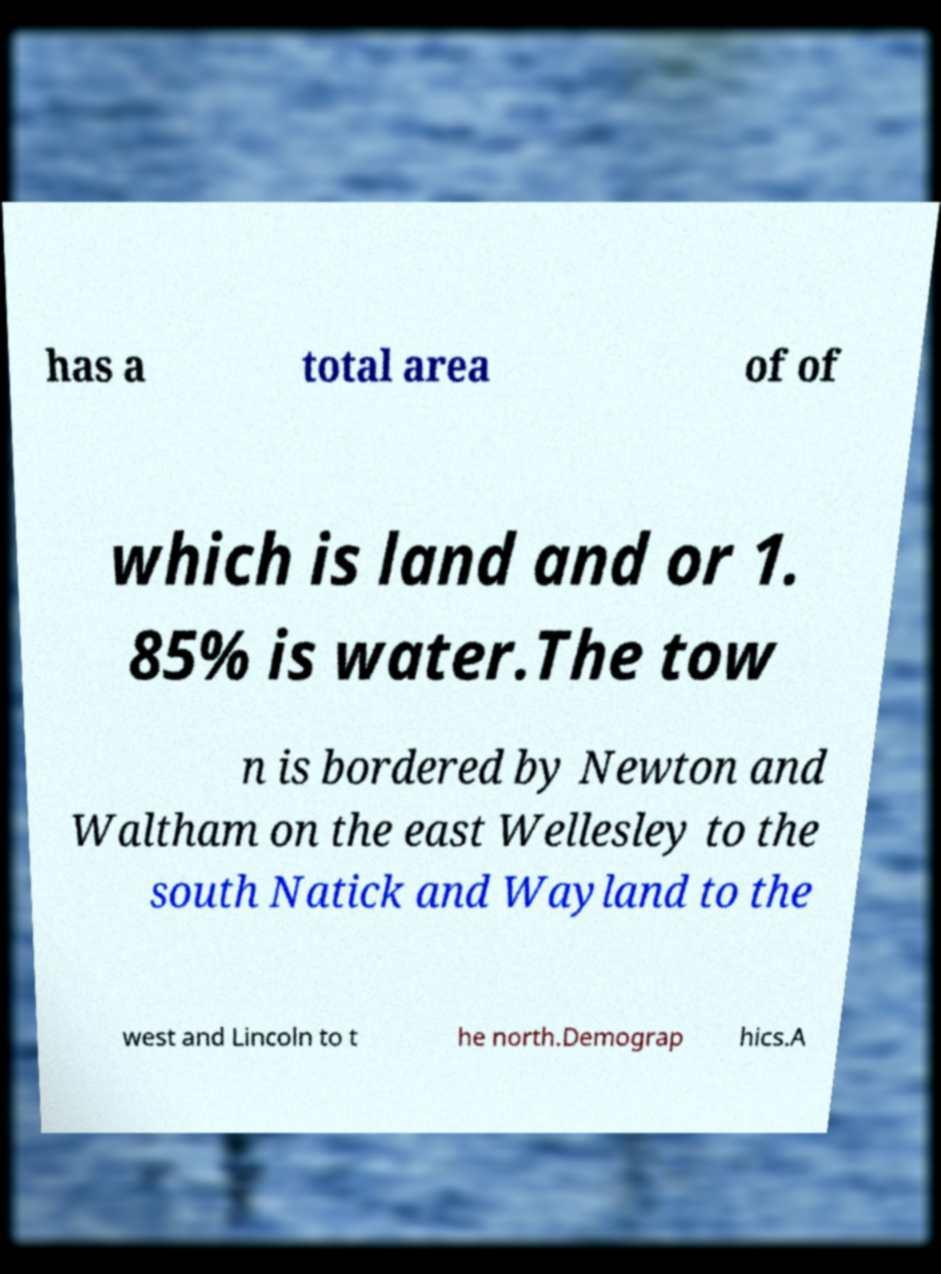Please read and relay the text visible in this image. What does it say? has a total area of of which is land and or 1. 85% is water.The tow n is bordered by Newton and Waltham on the east Wellesley to the south Natick and Wayland to the west and Lincoln to t he north.Demograp hics.A 